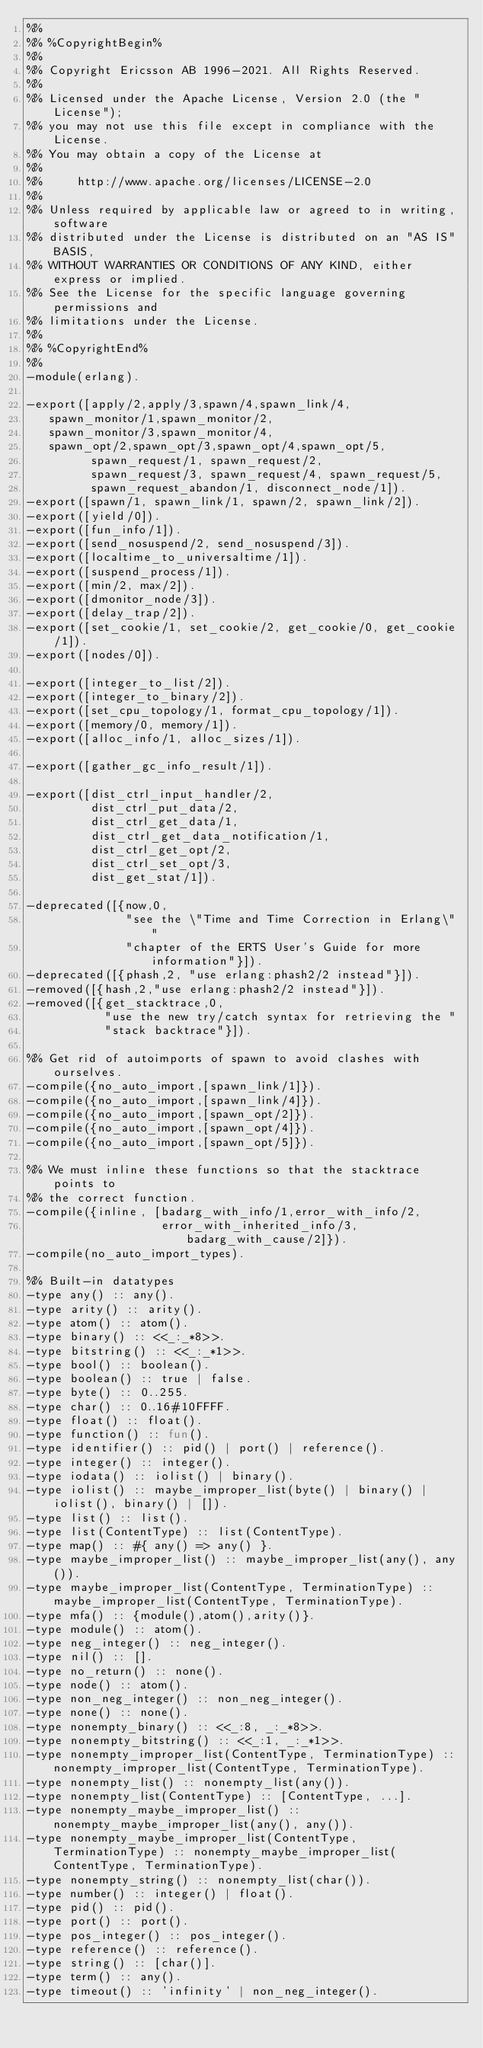<code> <loc_0><loc_0><loc_500><loc_500><_Erlang_>%%
%% %CopyrightBegin%
%%
%% Copyright Ericsson AB 1996-2021. All Rights Reserved.
%%
%% Licensed under the Apache License, Version 2.0 (the "License");
%% you may not use this file except in compliance with the License.
%% You may obtain a copy of the License at
%%
%%     http://www.apache.org/licenses/LICENSE-2.0
%%
%% Unless required by applicable law or agreed to in writing, software
%% distributed under the License is distributed on an "AS IS" BASIS,
%% WITHOUT WARRANTIES OR CONDITIONS OF ANY KIND, either express or implied.
%% See the License for the specific language governing permissions and
%% limitations under the License.
%%
%% %CopyrightEnd%
%%
-module(erlang).

-export([apply/2,apply/3,spawn/4,spawn_link/4,
	 spawn_monitor/1,spawn_monitor/2,
	 spawn_monitor/3,spawn_monitor/4,
	 spawn_opt/2,spawn_opt/3,spawn_opt/4,spawn_opt/5,
         spawn_request/1, spawn_request/2,
         spawn_request/3, spawn_request/4, spawn_request/5,
         spawn_request_abandon/1, disconnect_node/1]).
-export([spawn/1, spawn_link/1, spawn/2, spawn_link/2]).
-export([yield/0]).
-export([fun_info/1]).
-export([send_nosuspend/2, send_nosuspend/3]).
-export([localtime_to_universaltime/1]).
-export([suspend_process/1]).
-export([min/2, max/2]).
-export([dmonitor_node/3]).
-export([delay_trap/2]).
-export([set_cookie/1, set_cookie/2, get_cookie/0, get_cookie/1]).
-export([nodes/0]).

-export([integer_to_list/2]).
-export([integer_to_binary/2]).
-export([set_cpu_topology/1, format_cpu_topology/1]).
-export([memory/0, memory/1]).
-export([alloc_info/1, alloc_sizes/1]).

-export([gather_gc_info_result/1]).

-export([dist_ctrl_input_handler/2,
         dist_ctrl_put_data/2,
         dist_ctrl_get_data/1,
         dist_ctrl_get_data_notification/1,
         dist_ctrl_get_opt/2,
         dist_ctrl_set_opt/3,
         dist_get_stat/1]).

-deprecated([{now,0,
              "see the \"Time and Time Correction in Erlang\" "
              "chapter of the ERTS User's Guide for more information"}]).
-deprecated([{phash,2, "use erlang:phash2/2 instead"}]).
-removed([{hash,2,"use erlang:phash2/2 instead"}]).
-removed([{get_stacktrace,0,
           "use the new try/catch syntax for retrieving the "
           "stack backtrace"}]).

%% Get rid of autoimports of spawn to avoid clashes with ourselves.
-compile({no_auto_import,[spawn_link/1]}).
-compile({no_auto_import,[spawn_link/4]}).
-compile({no_auto_import,[spawn_opt/2]}).
-compile({no_auto_import,[spawn_opt/4]}).
-compile({no_auto_import,[spawn_opt/5]}).

%% We must inline these functions so that the stacktrace points to
%% the correct function.
-compile({inline, [badarg_with_info/1,error_with_info/2,
                   error_with_inherited_info/3,badarg_with_cause/2]}).
-compile(no_auto_import_types).

%% Built-in datatypes
-type any() :: any().
-type arity() :: arity().
-type atom() :: atom().
-type binary() :: <<_:_*8>>.
-type bitstring() :: <<_:_*1>>.
-type bool() :: boolean().
-type boolean() :: true | false.
-type byte() :: 0..255.
-type char() :: 0..16#10FFFF.
-type float() :: float().
-type function() :: fun().
-type identifier() :: pid() | port() | reference().
-type integer() :: integer().
-type iodata() :: iolist() | binary().
-type iolist() :: maybe_improper_list(byte() | binary() | iolist(), binary() | []).
-type list() :: list().
-type list(ContentType) :: list(ContentType).
-type map() :: #{ any() => any() }.
-type maybe_improper_list() :: maybe_improper_list(any(), any()).
-type maybe_improper_list(ContentType, TerminationType) :: maybe_improper_list(ContentType, TerminationType).
-type mfa() :: {module(),atom(),arity()}.
-type module() :: atom().
-type neg_integer() :: neg_integer().
-type nil() :: [].
-type no_return() :: none().
-type node() :: atom().
-type non_neg_integer() :: non_neg_integer().
-type none() :: none().
-type nonempty_binary() :: <<_:8, _:_*8>>.
-type nonempty_bitstring() :: <<_:1, _:_*1>>.
-type nonempty_improper_list(ContentType, TerminationType) :: nonempty_improper_list(ContentType, TerminationType).
-type nonempty_list() :: nonempty_list(any()).
-type nonempty_list(ContentType) :: [ContentType, ...].
-type nonempty_maybe_improper_list() :: nonempty_maybe_improper_list(any(), any()).
-type nonempty_maybe_improper_list(ContentType, TerminationType) :: nonempty_maybe_improper_list(ContentType, TerminationType).
-type nonempty_string() :: nonempty_list(char()).
-type number() :: integer() | float().
-type pid() :: pid().
-type port() :: port().
-type pos_integer() :: pos_integer().
-type reference() :: reference().
-type string() :: [char()].
-type term() :: any().
-type timeout() :: 'infinity' | non_neg_integer().</code> 